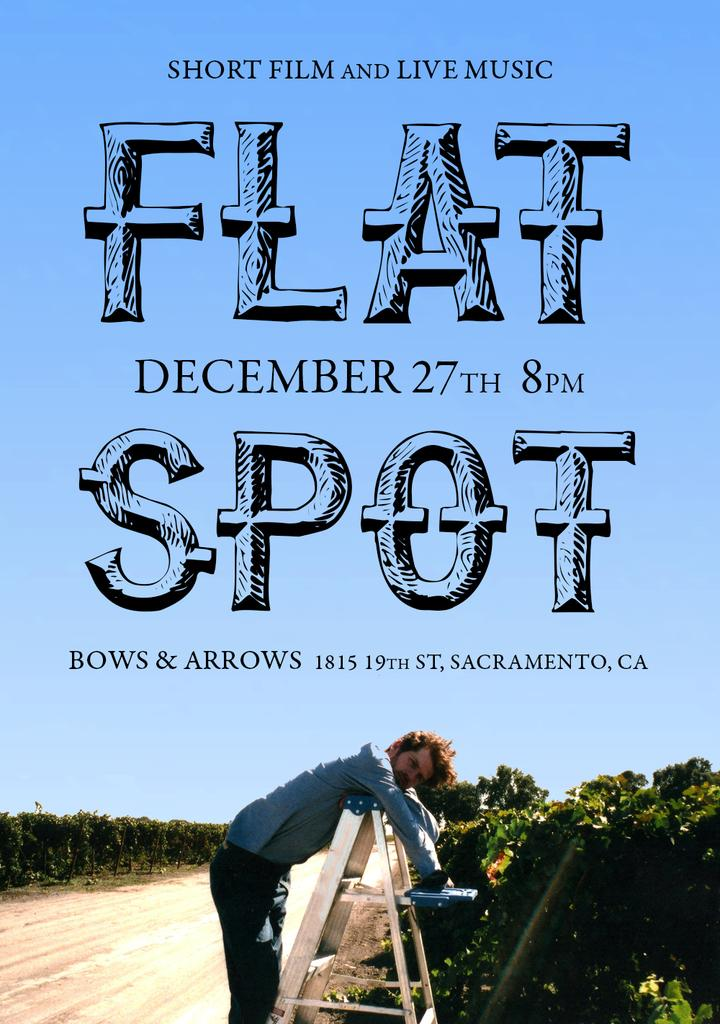What is the person in the image doing? The person is lying on a ladder in the image. What can be seen below the person? The ground is visible in the image. What type of vegetation is present in the image? There are trees and plants in the image. What is visible above the person? The sky is visible in the image. Is there any text present in the image? Yes, there is some text present in the image. How many spiders are crawling on the person's neck in the image? There are no spiders present in the image, and therefore no spiders can be seen on the person's neck. What type of produce is being harvested in the image? There is no produce or harvesting activity depicted in the image. 